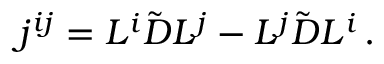Convert formula to latex. <formula><loc_0><loc_0><loc_500><loc_500>j ^ { i j } = L ^ { i } \tilde { D } L ^ { j } - L ^ { j } \tilde { D } L ^ { i } \, .</formula> 